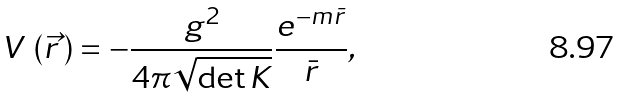Convert formula to latex. <formula><loc_0><loc_0><loc_500><loc_500>V \, \left ( \vec { r } \, \right ) = - \frac { g ^ { 2 } } { 4 \pi \sqrt { \det K } } \frac { e ^ { - m \bar { r } } } { \bar { r } } ,</formula> 